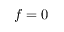<formula> <loc_0><loc_0><loc_500><loc_500>f = 0</formula> 